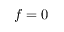<formula> <loc_0><loc_0><loc_500><loc_500>f = 0</formula> 